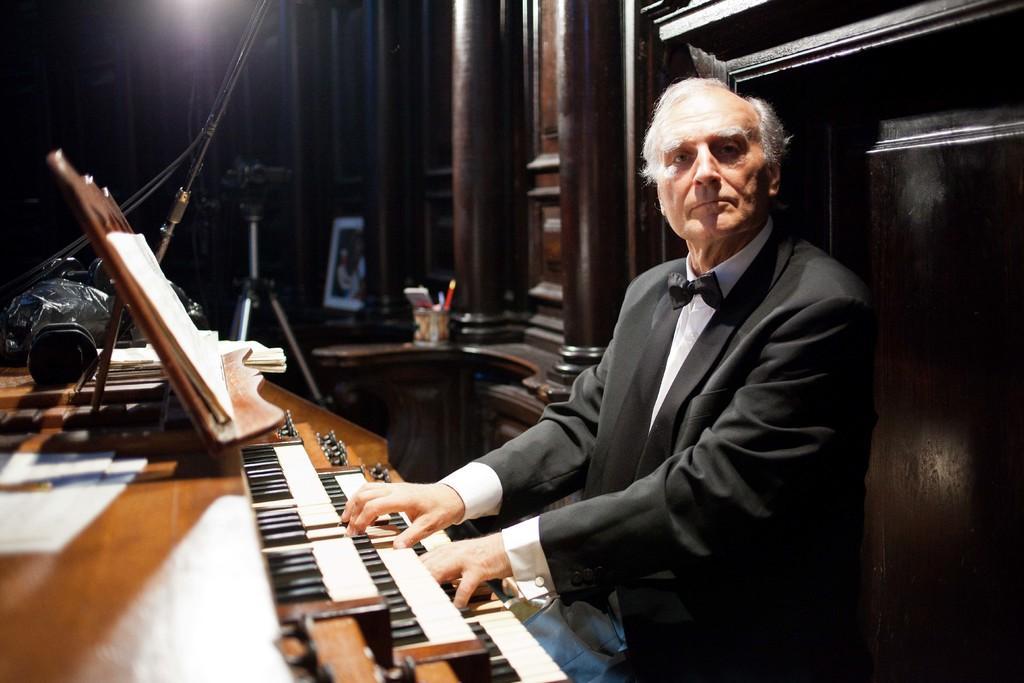In one or two sentences, can you explain what this image depicts? here we can see an old man playing a piano which is in front of him, here we can also see a camera with a stand. 